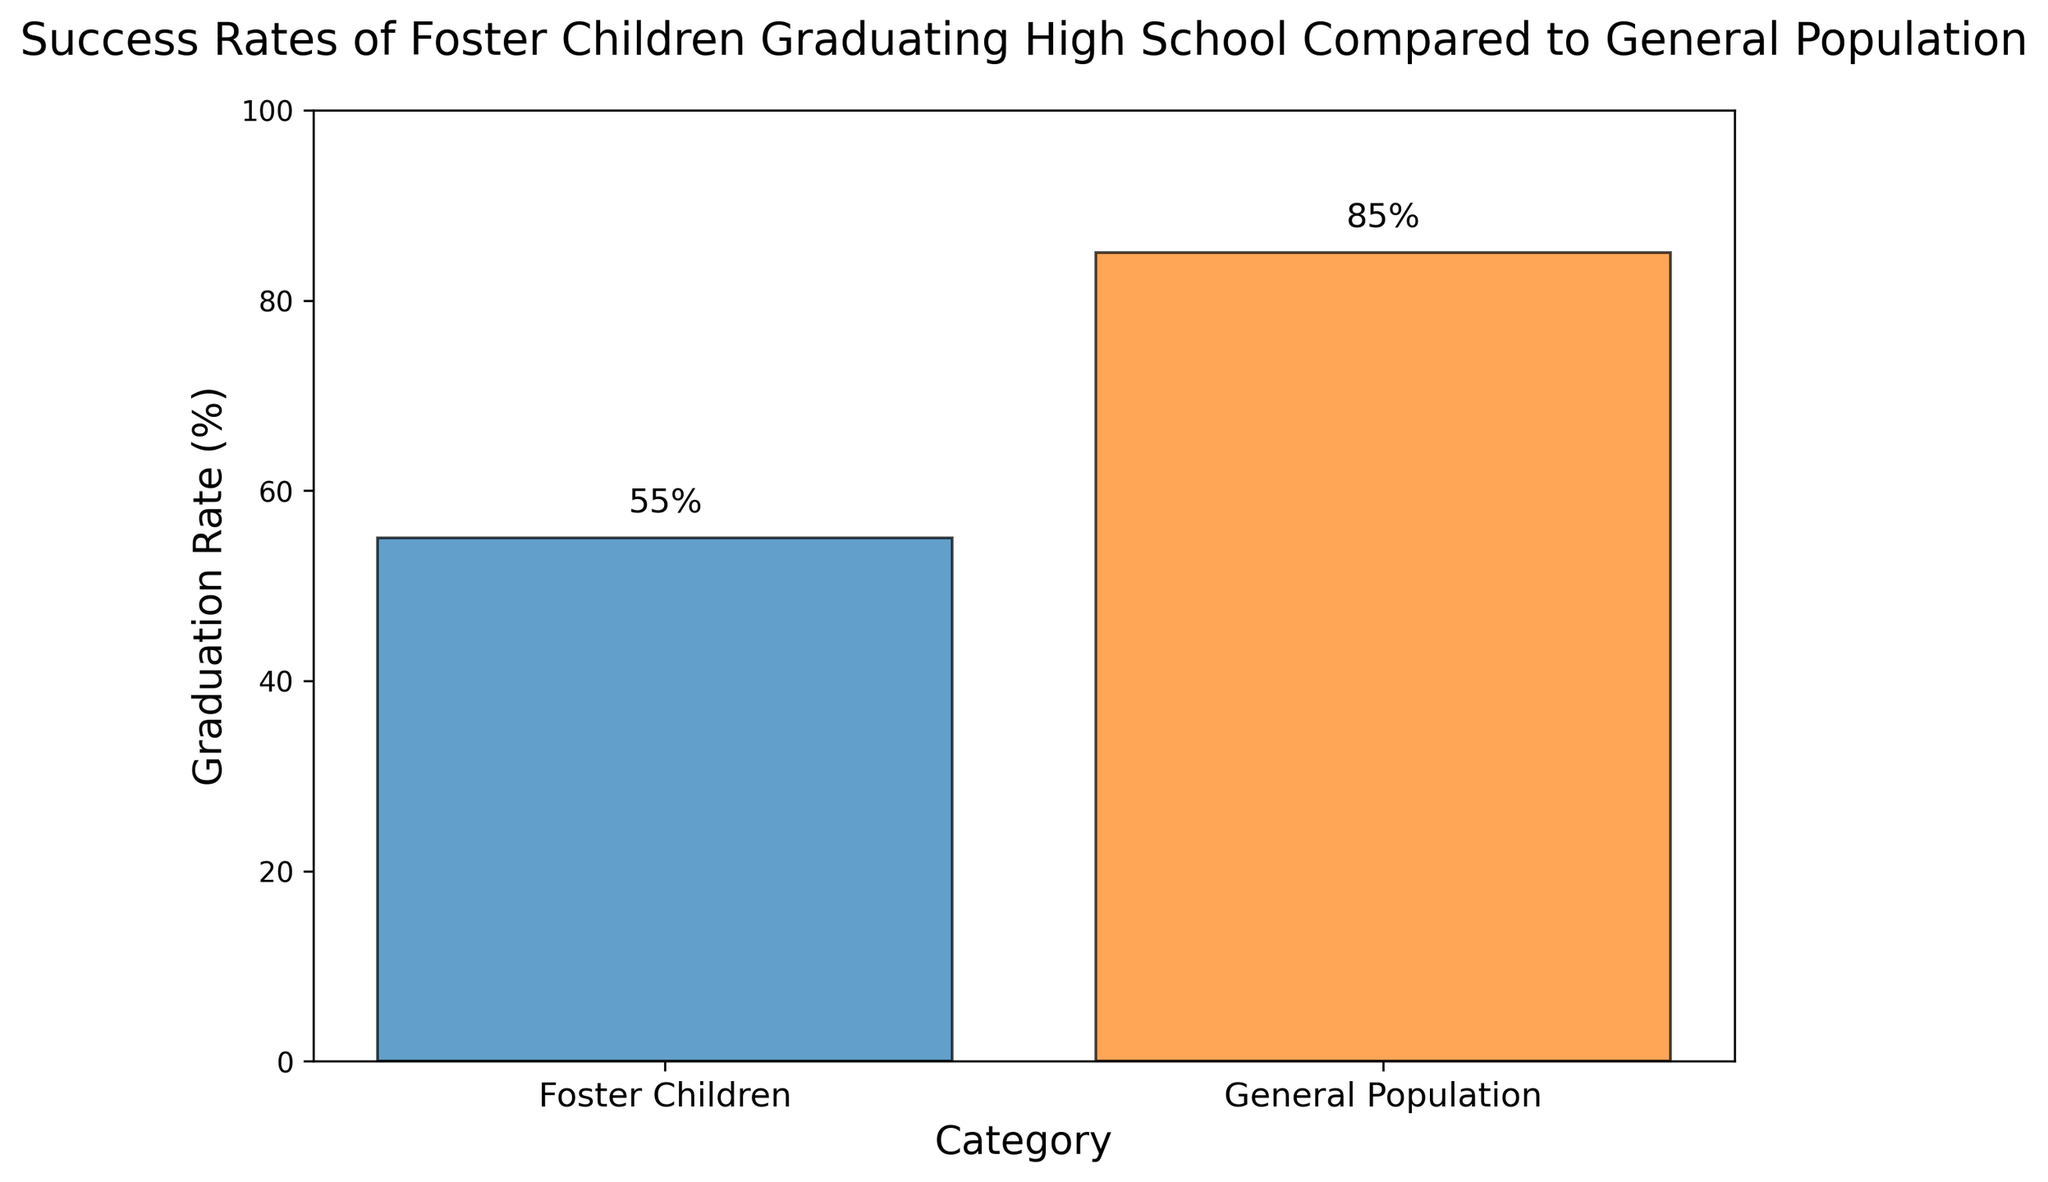what is the graduation rate for foster children? To find the graduation rate for foster children, look at the bar labeled 'Foster Children'. The height of this bar gives the percentage.
Answer: 55% how much higher is the graduation rate in the general population compared to foster children? To answer this, subtract the graduation rate of foster children (55%) from the graduation rate of the general population (85%). The result is the difference between the two rates.
Answer: 30% which category has a higher graduation rate? Compare the heights of the two bars. The bar for 'General Population' is higher than the bar for 'Foster Children', indicating a higher graduation rate for the general population.
Answer: General Population by how many percentage points does the graduation rate of foster children fall short of 100%? Subtract the graduation rate of foster children (55%) from 100%. This shows how many percentage points are needed to reach 100%.
Answer: 45% what is the average graduation rate of the two categories? Add the graduation rates of 'Foster Children' (55%) and 'General Population' (85%), then divide by 2 to find the average. The calculation is (55% + 85%) / 2.
Answer: 70% if you combine the two categories, what is the total graduation rate percentage? Sum the graduation rates of both categories: 55% (Foster Children) + 85% (General Population). This is the total combined percentage.
Answer: 140% what color represents the graduation rate for the general population? Look at the color of the bar labeled 'General Population'.
Answer: orange how much lower is the graduation rate of foster children compared to an ideal rate of 90%? Subtract the actual graduation rate of foster children (55%) from the ideal rate of 90%. This gives the shortfall.
Answer: 35% if the graduation rate of foster children were to increase by 25 percentage points, what would it be? Add 25 percentage points to the current graduation rate of foster children (55%). This gives the new rate.
Answer: 80% which category would benefit more from a 10% increase in their graduation rates? Calculate 10% of each category's graduation rate and determine which group's new rate would have a more significant relative improvement. For Foster Children, a 10% increase is 55% + 10% = 65%. For the General Population, a 10% increase is 85% + 10% = 95%. Foster Children would see a relatively greater improvement since they start from a lower base.
Answer: Foster Children 